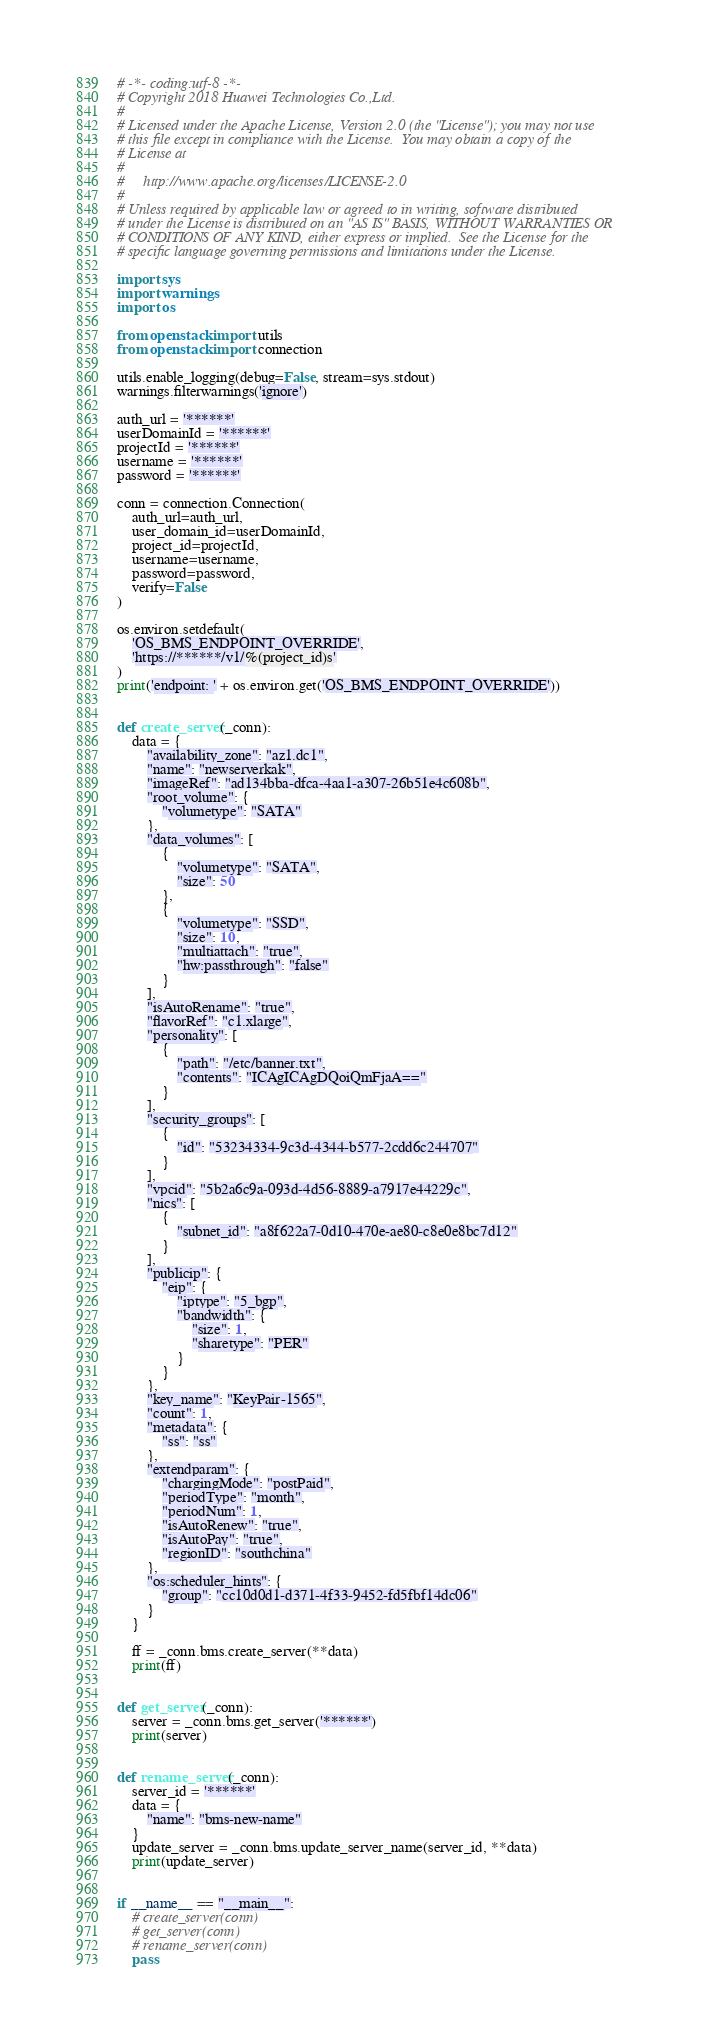Convert code to text. <code><loc_0><loc_0><loc_500><loc_500><_Python_># -*- coding:utf-8 -*-
# Copyright 2018 Huawei Technologies Co.,Ltd.
#
# Licensed under the Apache License, Version 2.0 (the "License"); you may not use
# this file except in compliance with the License.  You may obtain a copy of the
# License at
#
#     http://www.apache.org/licenses/LICENSE-2.0
#
# Unless required by applicable law or agreed to in writing, software distributed
# under the License is distributed on an "AS IS" BASIS, WITHOUT WARRANTIES OR
# CONDITIONS OF ANY KIND, either express or implied.  See the License for the
# specific language governing permissions and limitations under the License.

import sys
import warnings
import os

from openstack import utils
from openstack import connection

utils.enable_logging(debug=False, stream=sys.stdout)
warnings.filterwarnings('ignore')

auth_url = '******'
userDomainId = '******'
projectId = '******'
username = '******'
password = '******'

conn = connection.Connection(
    auth_url=auth_url,
    user_domain_id=userDomainId,
    project_id=projectId,
    username=username,
    password=password,
    verify=False
)

os.environ.setdefault(
    'OS_BMS_ENDPOINT_OVERRIDE',
    'https://******/v1/%(project_id)s'
)
print('endpoint: ' + os.environ.get('OS_BMS_ENDPOINT_OVERRIDE'))


def create_server(_conn):
    data = {
        "availability_zone": "az1.dc1",
        "name": "newserverkak",
        "imageRef": "ad134bba-dfca-4aa1-a307-26b51e4c608b",
        "root_volume": {
            "volumetype": "SATA"
        },
        "data_volumes": [
            {
                "volumetype": "SATA",
                "size": 50
            },
            {
                "volumetype": "SSD",
                "size": 10,
                "multiattach": "true",
                "hw:passthrough": "false"
            }
        ],
        "isAutoRename": "true",
        "flavorRef": "c1.xlarge",
        "personality": [
            {
                "path": "/etc/banner.txt",
                "contents": "ICAgICAgDQoiQmFjaA=="
            }
        ],
        "security_groups": [
            {
                "id": "53234334-9c3d-4344-b577-2cdd6c244707"
            }
        ],
        "vpcid": "5b2a6c9a-093d-4d56-8889-a7917e44229c",
        "nics": [
            {
                "subnet_id": "a8f622a7-0d10-470e-ae80-c8e0e8bc7d12"
            }
        ],
        "publicip": {
            "eip": {
                "iptype": "5_bgp",
                "bandwidth": {
                    "size": 1,
                    "sharetype": "PER"
                }
            }
        },
        "key_name": "KeyPair-1565",
        "count": 1,
        "metadata": {
            "ss": "ss"
        },
        "extendparam": {
            "chargingMode": "postPaid",
            "periodType": "month",
            "periodNum": 1,
            "isAutoRenew": "true",
            "isAutoPay": "true",
            "regionID": "southchina"
        },
        "os:scheduler_hints": {
            "group": "cc10d0d1-d371-4f33-9452-fd5fbf14dc06"
        }
    }

    ff = _conn.bms.create_server(**data)
    print(ff)


def get_server(_conn):
    server = _conn.bms.get_server('******')
    print(server)


def rename_server(_conn):
    server_id = '******'
    data = {
        "name": "bms-new-name"
    }
    update_server = _conn.bms.update_server_name(server_id, **data)
    print(update_server)


if __name__ == "__main__":
    # create_server(conn)
    # get_server(conn)
    # rename_server(conn)
    pass
</code> 